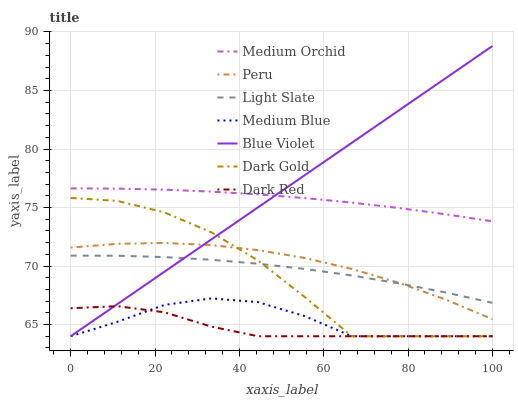Does Dark Red have the minimum area under the curve?
Answer yes or no. Yes. Does Blue Violet have the maximum area under the curve?
Answer yes or no. Yes. Does Light Slate have the minimum area under the curve?
Answer yes or no. No. Does Light Slate have the maximum area under the curve?
Answer yes or no. No. Is Blue Violet the smoothest?
Answer yes or no. Yes. Is Dark Gold the roughest?
Answer yes or no. Yes. Is Light Slate the smoothest?
Answer yes or no. No. Is Light Slate the roughest?
Answer yes or no. No. Does Dark Gold have the lowest value?
Answer yes or no. Yes. Does Light Slate have the lowest value?
Answer yes or no. No. Does Blue Violet have the highest value?
Answer yes or no. Yes. Does Light Slate have the highest value?
Answer yes or no. No. Is Medium Blue less than Peru?
Answer yes or no. Yes. Is Medium Orchid greater than Dark Gold?
Answer yes or no. Yes. Does Medium Blue intersect Dark Red?
Answer yes or no. Yes. Is Medium Blue less than Dark Red?
Answer yes or no. No. Is Medium Blue greater than Dark Red?
Answer yes or no. No. Does Medium Blue intersect Peru?
Answer yes or no. No. 